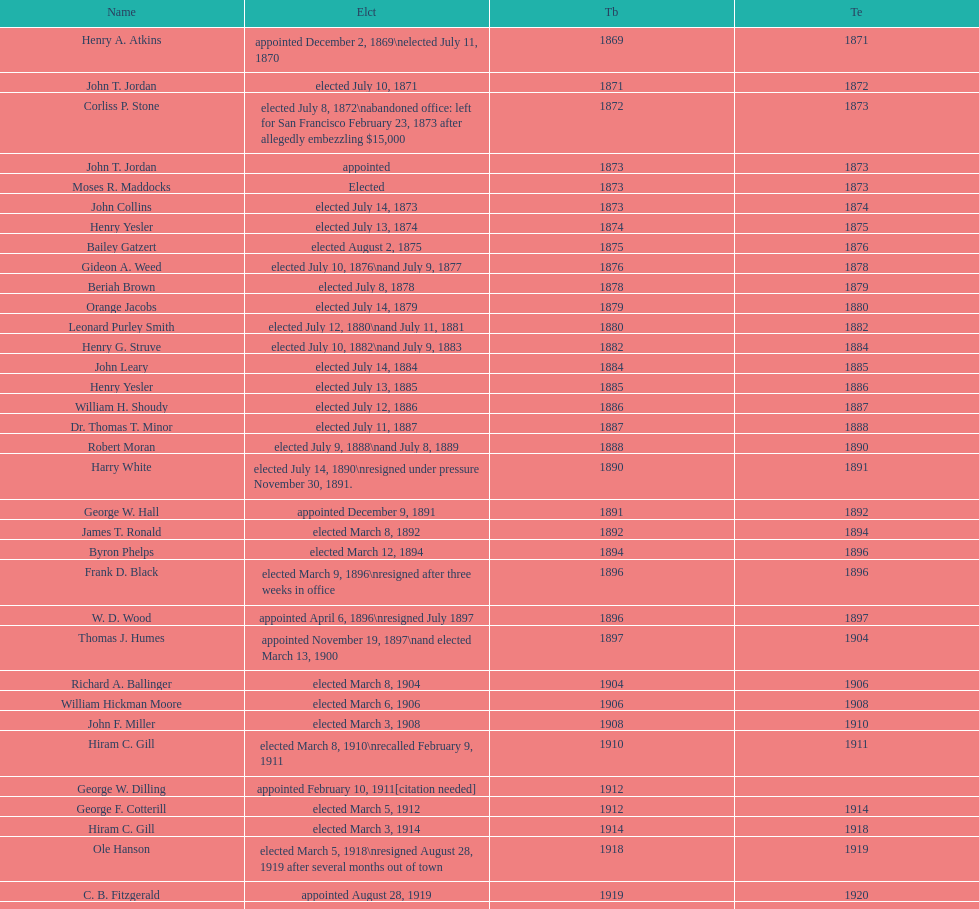What is the number of mayors with the first name of john? 6. 